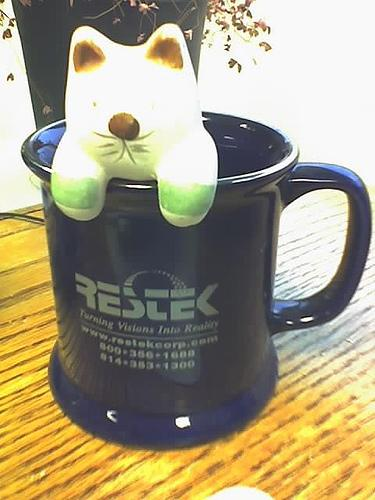Where is Restek's headquarters? bellefonte pa 